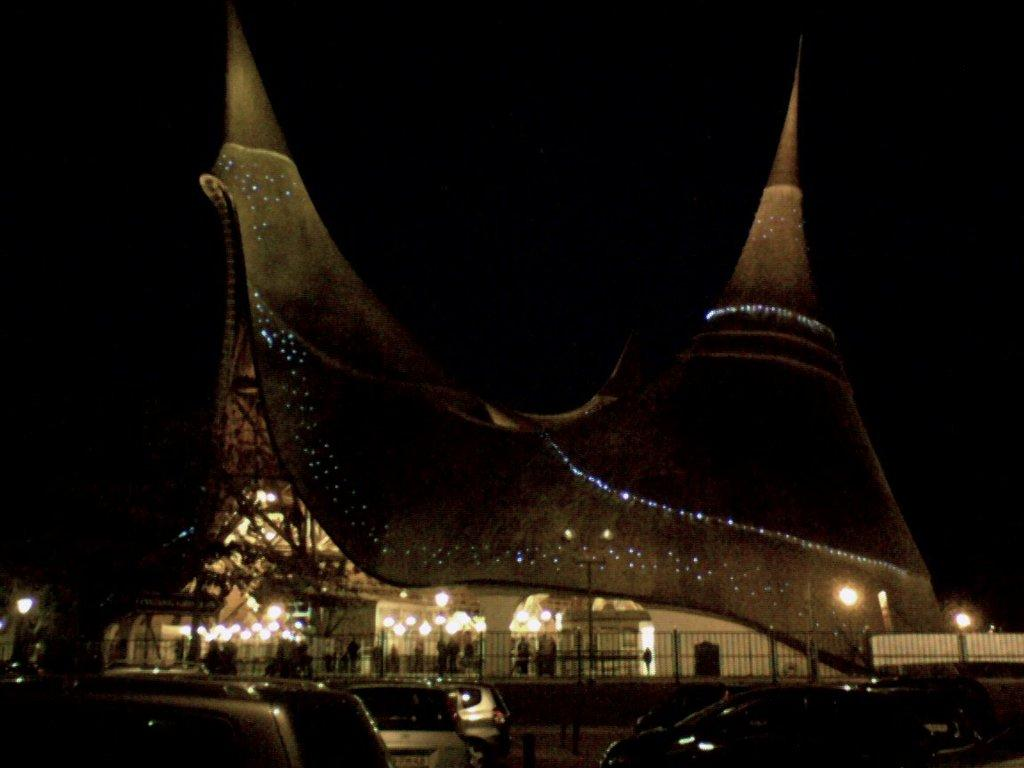What type of structure is visible in the image? There is a building with lights in the image. Can you describe the people in the image? There are people standing in the image. What else can be seen in the image besides the building and people? There are vehicles, a fence, and a pole in the image. How would you describe the lighting conditions in the image? The background of the image is dark. How many tanks are visible in the image? There are no tanks present in the image. Are the people in the image raking leaves? There is no indication in the image that the people are raking leaves or using a rake. 